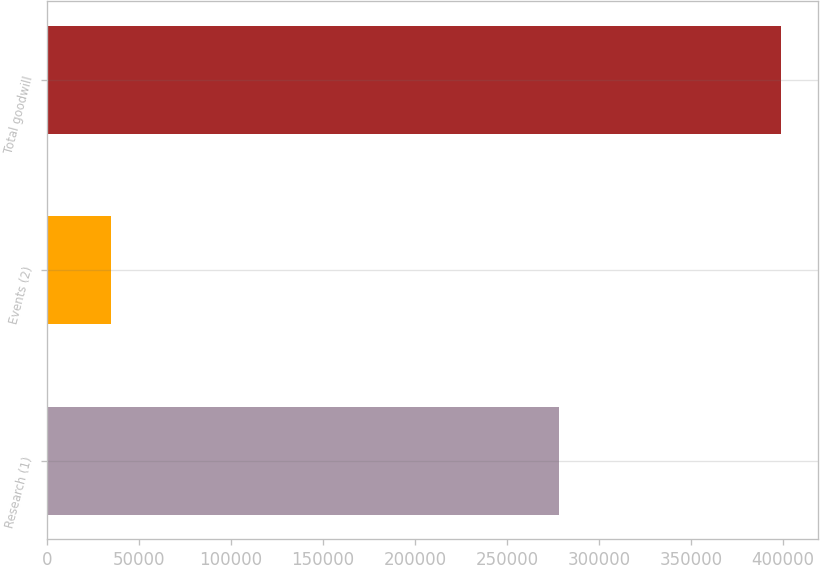Convert chart. <chart><loc_0><loc_0><loc_500><loc_500><bar_chart><fcel>Research (1)<fcel>Events (2)<fcel>Total goodwill<nl><fcel>278079<fcel>34528<fcel>398737<nl></chart> 